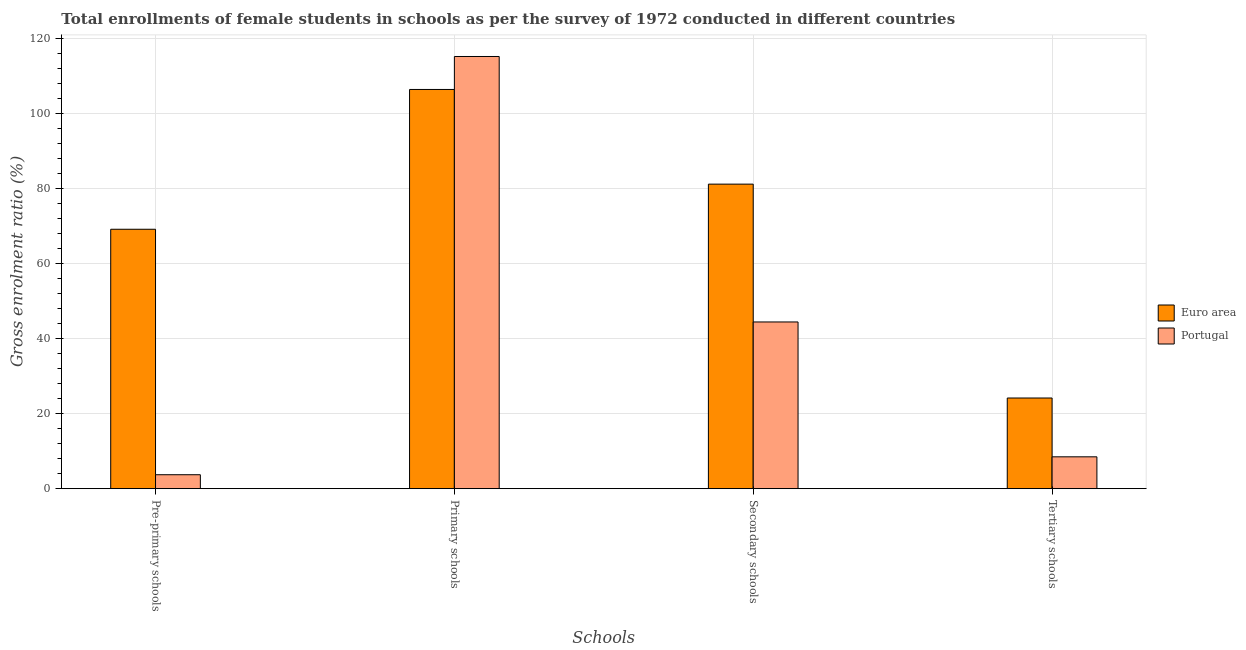How many different coloured bars are there?
Your response must be concise. 2. How many groups of bars are there?
Provide a succinct answer. 4. How many bars are there on the 4th tick from the right?
Your answer should be very brief. 2. What is the label of the 1st group of bars from the left?
Provide a short and direct response. Pre-primary schools. What is the gross enrolment ratio(female) in secondary schools in Euro area?
Keep it short and to the point. 81.14. Across all countries, what is the maximum gross enrolment ratio(female) in pre-primary schools?
Your response must be concise. 69.12. Across all countries, what is the minimum gross enrolment ratio(female) in tertiary schools?
Your answer should be very brief. 8.49. In which country was the gross enrolment ratio(female) in secondary schools minimum?
Ensure brevity in your answer.  Portugal. What is the total gross enrolment ratio(female) in secondary schools in the graph?
Make the answer very short. 125.56. What is the difference between the gross enrolment ratio(female) in secondary schools in Euro area and that in Portugal?
Your answer should be compact. 36.72. What is the difference between the gross enrolment ratio(female) in tertiary schools in Portugal and the gross enrolment ratio(female) in primary schools in Euro area?
Your answer should be compact. -97.88. What is the average gross enrolment ratio(female) in pre-primary schools per country?
Ensure brevity in your answer.  36.42. What is the difference between the gross enrolment ratio(female) in secondary schools and gross enrolment ratio(female) in primary schools in Portugal?
Your response must be concise. -70.73. What is the ratio of the gross enrolment ratio(female) in secondary schools in Euro area to that in Portugal?
Keep it short and to the point. 1.83. Is the difference between the gross enrolment ratio(female) in secondary schools in Euro area and Portugal greater than the difference between the gross enrolment ratio(female) in primary schools in Euro area and Portugal?
Your answer should be compact. Yes. What is the difference between the highest and the second highest gross enrolment ratio(female) in pre-primary schools?
Provide a succinct answer. 65.4. What is the difference between the highest and the lowest gross enrolment ratio(female) in secondary schools?
Your answer should be compact. 36.72. Is the sum of the gross enrolment ratio(female) in pre-primary schools in Portugal and Euro area greater than the maximum gross enrolment ratio(female) in tertiary schools across all countries?
Offer a terse response. Yes. What does the 2nd bar from the left in Tertiary schools represents?
Give a very brief answer. Portugal. How many countries are there in the graph?
Offer a terse response. 2. What is the difference between two consecutive major ticks on the Y-axis?
Your response must be concise. 20. Are the values on the major ticks of Y-axis written in scientific E-notation?
Your answer should be very brief. No. Does the graph contain any zero values?
Provide a succinct answer. No. Does the graph contain grids?
Your answer should be very brief. Yes. How many legend labels are there?
Give a very brief answer. 2. How are the legend labels stacked?
Provide a succinct answer. Vertical. What is the title of the graph?
Offer a terse response. Total enrollments of female students in schools as per the survey of 1972 conducted in different countries. Does "Heavily indebted poor countries" appear as one of the legend labels in the graph?
Ensure brevity in your answer.  No. What is the label or title of the X-axis?
Provide a short and direct response. Schools. What is the label or title of the Y-axis?
Your response must be concise. Gross enrolment ratio (%). What is the Gross enrolment ratio (%) in Euro area in Pre-primary schools?
Ensure brevity in your answer.  69.12. What is the Gross enrolment ratio (%) in Portugal in Pre-primary schools?
Provide a short and direct response. 3.72. What is the Gross enrolment ratio (%) in Euro area in Primary schools?
Give a very brief answer. 106.37. What is the Gross enrolment ratio (%) of Portugal in Primary schools?
Provide a short and direct response. 115.15. What is the Gross enrolment ratio (%) in Euro area in Secondary schools?
Offer a very short reply. 81.14. What is the Gross enrolment ratio (%) of Portugal in Secondary schools?
Offer a terse response. 44.42. What is the Gross enrolment ratio (%) in Euro area in Tertiary schools?
Offer a terse response. 24.16. What is the Gross enrolment ratio (%) of Portugal in Tertiary schools?
Offer a terse response. 8.49. Across all Schools, what is the maximum Gross enrolment ratio (%) of Euro area?
Offer a very short reply. 106.37. Across all Schools, what is the maximum Gross enrolment ratio (%) of Portugal?
Make the answer very short. 115.15. Across all Schools, what is the minimum Gross enrolment ratio (%) of Euro area?
Provide a short and direct response. 24.16. Across all Schools, what is the minimum Gross enrolment ratio (%) of Portugal?
Offer a very short reply. 3.72. What is the total Gross enrolment ratio (%) in Euro area in the graph?
Provide a succinct answer. 280.79. What is the total Gross enrolment ratio (%) in Portugal in the graph?
Offer a terse response. 171.78. What is the difference between the Gross enrolment ratio (%) of Euro area in Pre-primary schools and that in Primary schools?
Offer a terse response. -37.25. What is the difference between the Gross enrolment ratio (%) of Portugal in Pre-primary schools and that in Primary schools?
Your response must be concise. -111.44. What is the difference between the Gross enrolment ratio (%) of Euro area in Pre-primary schools and that in Secondary schools?
Keep it short and to the point. -12.02. What is the difference between the Gross enrolment ratio (%) of Portugal in Pre-primary schools and that in Secondary schools?
Give a very brief answer. -40.7. What is the difference between the Gross enrolment ratio (%) of Euro area in Pre-primary schools and that in Tertiary schools?
Your response must be concise. 44.96. What is the difference between the Gross enrolment ratio (%) in Portugal in Pre-primary schools and that in Tertiary schools?
Keep it short and to the point. -4.77. What is the difference between the Gross enrolment ratio (%) of Euro area in Primary schools and that in Secondary schools?
Keep it short and to the point. 25.22. What is the difference between the Gross enrolment ratio (%) of Portugal in Primary schools and that in Secondary schools?
Provide a short and direct response. 70.73. What is the difference between the Gross enrolment ratio (%) of Euro area in Primary schools and that in Tertiary schools?
Give a very brief answer. 82.21. What is the difference between the Gross enrolment ratio (%) in Portugal in Primary schools and that in Tertiary schools?
Your response must be concise. 106.67. What is the difference between the Gross enrolment ratio (%) of Euro area in Secondary schools and that in Tertiary schools?
Provide a succinct answer. 56.98. What is the difference between the Gross enrolment ratio (%) in Portugal in Secondary schools and that in Tertiary schools?
Your answer should be compact. 35.93. What is the difference between the Gross enrolment ratio (%) of Euro area in Pre-primary schools and the Gross enrolment ratio (%) of Portugal in Primary schools?
Your response must be concise. -46.03. What is the difference between the Gross enrolment ratio (%) of Euro area in Pre-primary schools and the Gross enrolment ratio (%) of Portugal in Secondary schools?
Offer a terse response. 24.7. What is the difference between the Gross enrolment ratio (%) of Euro area in Pre-primary schools and the Gross enrolment ratio (%) of Portugal in Tertiary schools?
Offer a terse response. 60.64. What is the difference between the Gross enrolment ratio (%) of Euro area in Primary schools and the Gross enrolment ratio (%) of Portugal in Secondary schools?
Make the answer very short. 61.95. What is the difference between the Gross enrolment ratio (%) of Euro area in Primary schools and the Gross enrolment ratio (%) of Portugal in Tertiary schools?
Provide a succinct answer. 97.88. What is the difference between the Gross enrolment ratio (%) of Euro area in Secondary schools and the Gross enrolment ratio (%) of Portugal in Tertiary schools?
Make the answer very short. 72.66. What is the average Gross enrolment ratio (%) in Euro area per Schools?
Your answer should be compact. 70.2. What is the average Gross enrolment ratio (%) in Portugal per Schools?
Make the answer very short. 42.94. What is the difference between the Gross enrolment ratio (%) of Euro area and Gross enrolment ratio (%) of Portugal in Pre-primary schools?
Your response must be concise. 65.4. What is the difference between the Gross enrolment ratio (%) in Euro area and Gross enrolment ratio (%) in Portugal in Primary schools?
Provide a short and direct response. -8.79. What is the difference between the Gross enrolment ratio (%) in Euro area and Gross enrolment ratio (%) in Portugal in Secondary schools?
Offer a terse response. 36.72. What is the difference between the Gross enrolment ratio (%) of Euro area and Gross enrolment ratio (%) of Portugal in Tertiary schools?
Provide a succinct answer. 15.67. What is the ratio of the Gross enrolment ratio (%) in Euro area in Pre-primary schools to that in Primary schools?
Your answer should be very brief. 0.65. What is the ratio of the Gross enrolment ratio (%) in Portugal in Pre-primary schools to that in Primary schools?
Your response must be concise. 0.03. What is the ratio of the Gross enrolment ratio (%) in Euro area in Pre-primary schools to that in Secondary schools?
Your response must be concise. 0.85. What is the ratio of the Gross enrolment ratio (%) in Portugal in Pre-primary schools to that in Secondary schools?
Your answer should be compact. 0.08. What is the ratio of the Gross enrolment ratio (%) of Euro area in Pre-primary schools to that in Tertiary schools?
Keep it short and to the point. 2.86. What is the ratio of the Gross enrolment ratio (%) of Portugal in Pre-primary schools to that in Tertiary schools?
Provide a succinct answer. 0.44. What is the ratio of the Gross enrolment ratio (%) of Euro area in Primary schools to that in Secondary schools?
Offer a very short reply. 1.31. What is the ratio of the Gross enrolment ratio (%) of Portugal in Primary schools to that in Secondary schools?
Your answer should be compact. 2.59. What is the ratio of the Gross enrolment ratio (%) in Euro area in Primary schools to that in Tertiary schools?
Offer a terse response. 4.4. What is the ratio of the Gross enrolment ratio (%) of Portugal in Primary schools to that in Tertiary schools?
Offer a very short reply. 13.57. What is the ratio of the Gross enrolment ratio (%) in Euro area in Secondary schools to that in Tertiary schools?
Provide a succinct answer. 3.36. What is the ratio of the Gross enrolment ratio (%) in Portugal in Secondary schools to that in Tertiary schools?
Your answer should be very brief. 5.23. What is the difference between the highest and the second highest Gross enrolment ratio (%) of Euro area?
Ensure brevity in your answer.  25.22. What is the difference between the highest and the second highest Gross enrolment ratio (%) in Portugal?
Your answer should be very brief. 70.73. What is the difference between the highest and the lowest Gross enrolment ratio (%) of Euro area?
Ensure brevity in your answer.  82.21. What is the difference between the highest and the lowest Gross enrolment ratio (%) in Portugal?
Your answer should be very brief. 111.44. 